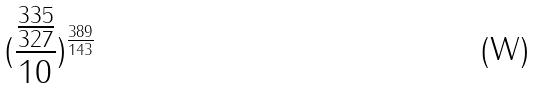Convert formula to latex. <formula><loc_0><loc_0><loc_500><loc_500>( \frac { \frac { 3 3 5 } { 3 2 7 } } { 1 0 } ) ^ { \frac { 3 8 9 } { 1 4 3 } }</formula> 